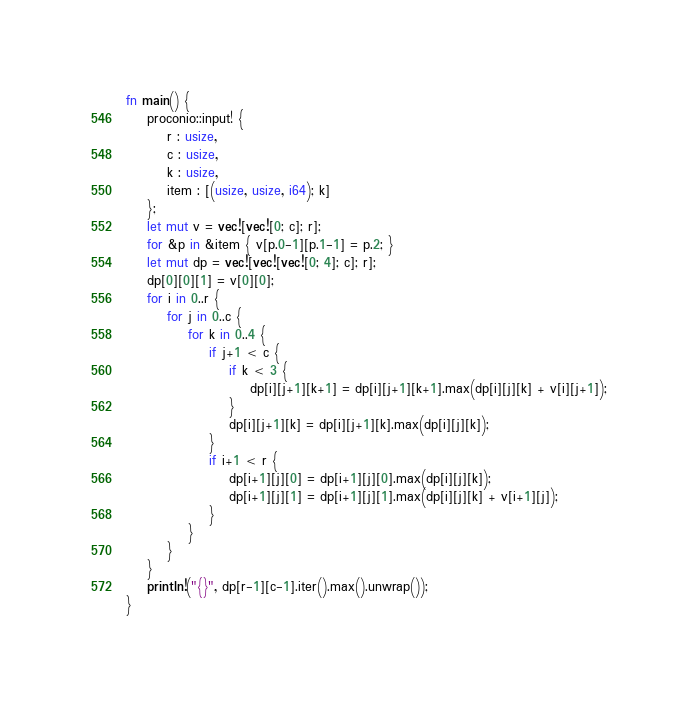<code> <loc_0><loc_0><loc_500><loc_500><_Rust_>fn main() {
    proconio::input! {
        r : usize,
        c : usize,
        k : usize,
        item : [(usize, usize, i64); k]
    };
    let mut v = vec![vec![0; c]; r];
    for &p in &item { v[p.0-1][p.1-1] = p.2; }
    let mut dp = vec![vec![vec![0; 4]; c]; r];
    dp[0][0][1] = v[0][0];
    for i in 0..r {
        for j in 0..c {
            for k in 0..4 {
                if j+1 < c {
                    if k < 3 {
                        dp[i][j+1][k+1] = dp[i][j+1][k+1].max(dp[i][j][k] + v[i][j+1]);
                    }
                    dp[i][j+1][k] = dp[i][j+1][k].max(dp[i][j][k]);
                }
                if i+1 < r {
                    dp[i+1][j][0] = dp[i+1][j][0].max(dp[i][j][k]);
                    dp[i+1][j][1] = dp[i+1][j][1].max(dp[i][j][k] + v[i+1][j]);
                }
            }
        }
    }
    println!("{}", dp[r-1][c-1].iter().max().unwrap());
}
</code> 